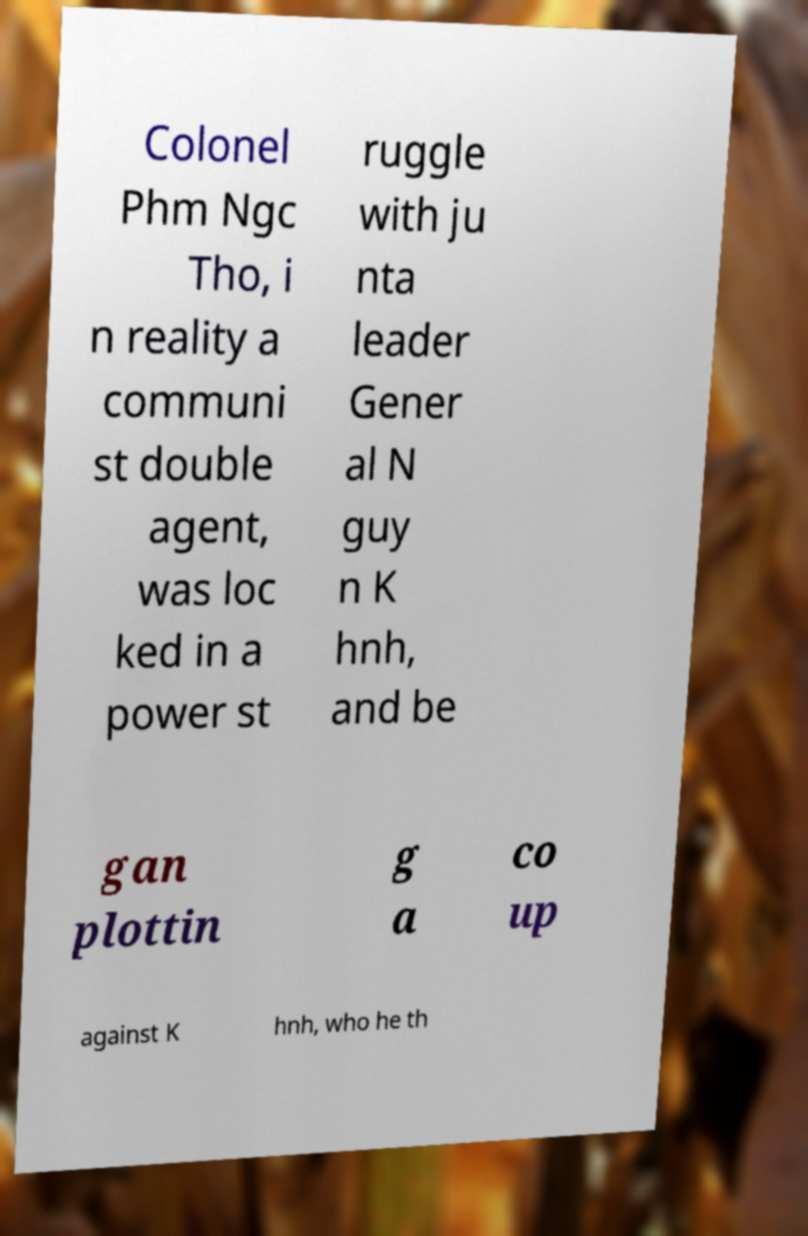I need the written content from this picture converted into text. Can you do that? Colonel Phm Ngc Tho, i n reality a communi st double agent, was loc ked in a power st ruggle with ju nta leader Gener al N guy n K hnh, and be gan plottin g a co up against K hnh, who he th 